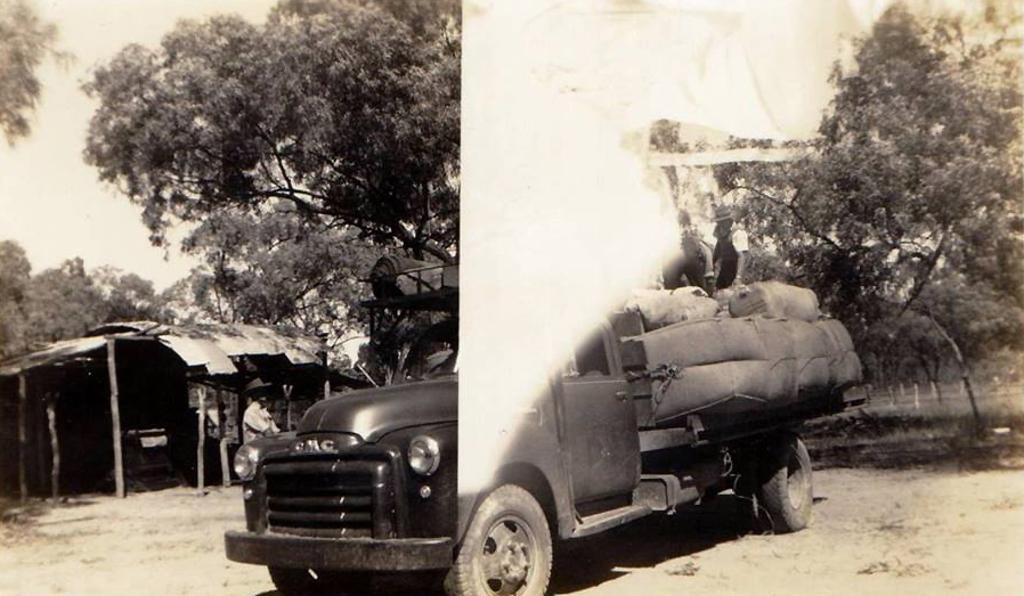In one or two sentences, can you explain what this image depicts? In this black and white image, where we can see a vehicle, trees, it seems like white shade and shed. 